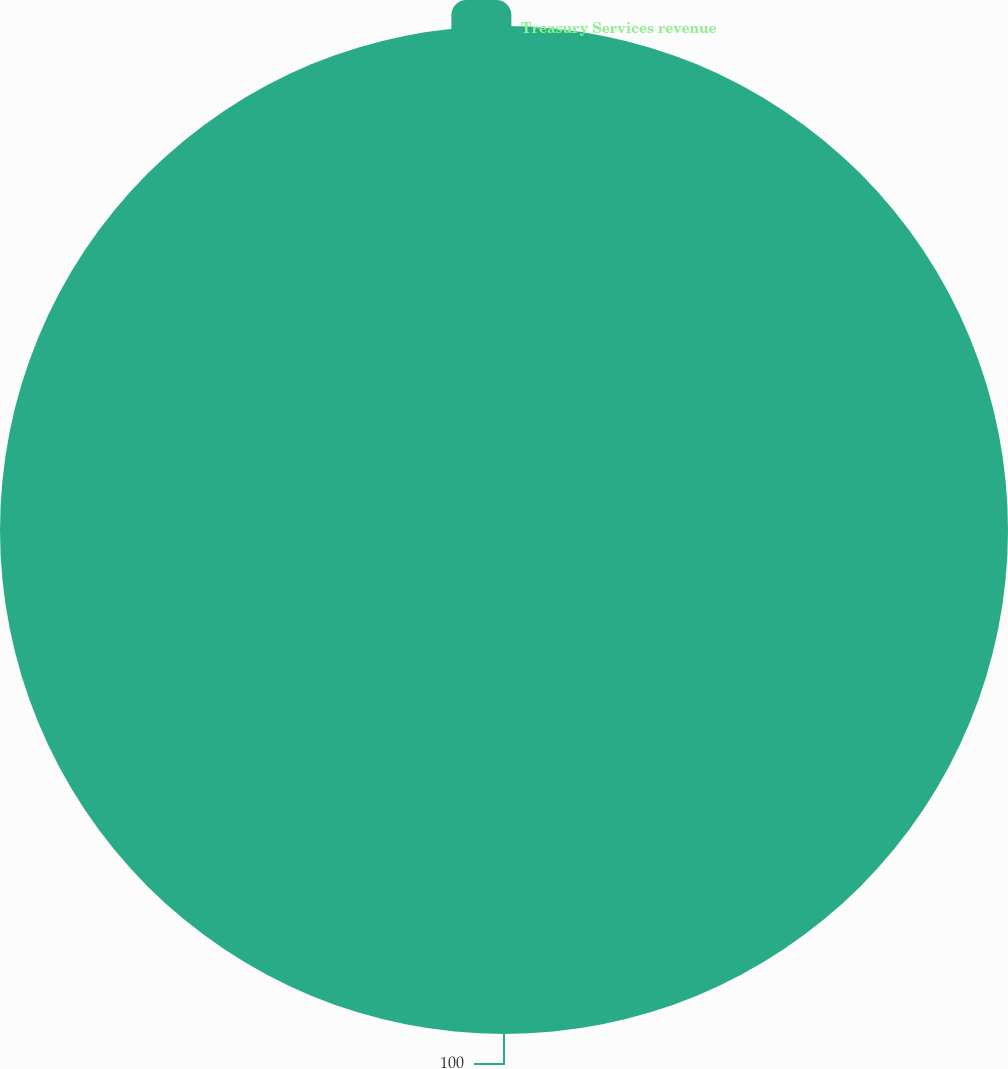Convert chart. <chart><loc_0><loc_0><loc_500><loc_500><pie_chart><fcel>Treasury Services revenue<nl><fcel>100.0%<nl></chart> 